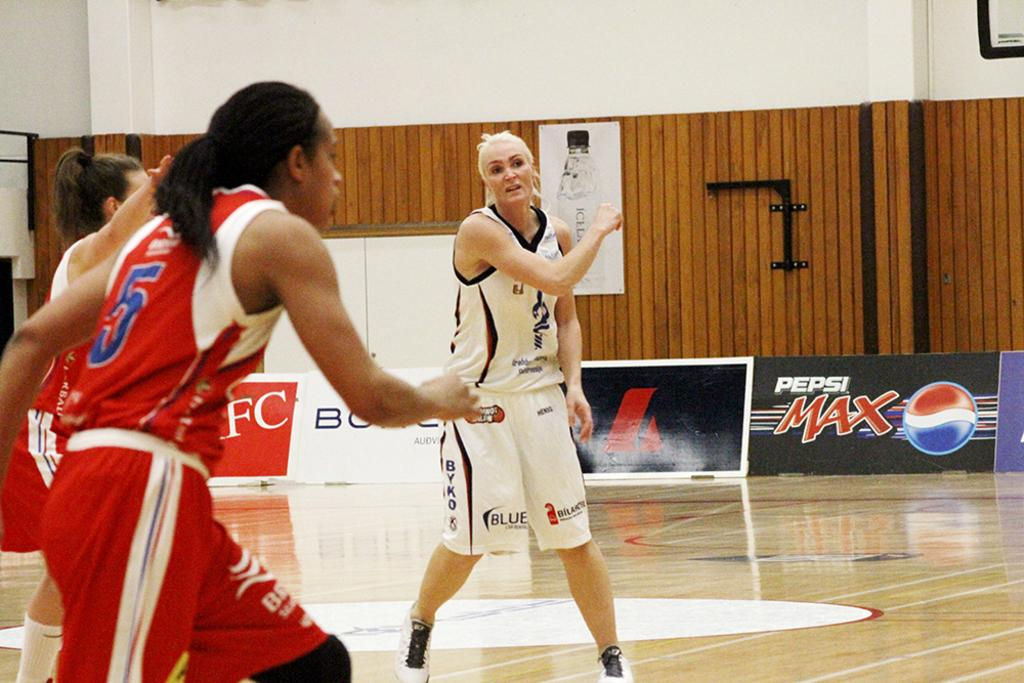Provide a one-sentence caption for the provided image. Basketball play number two in white playing number 5 in red. 